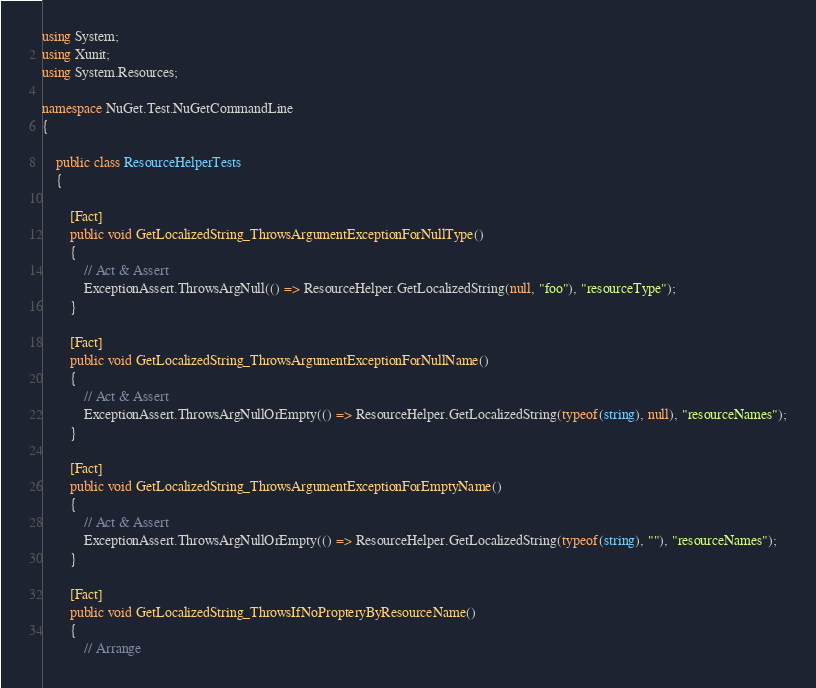<code> <loc_0><loc_0><loc_500><loc_500><_C#_>using System;
using Xunit;
using System.Resources;

namespace NuGet.Test.NuGetCommandLine
{

    public class ResourceHelperTests
    {

        [Fact]
        public void GetLocalizedString_ThrowsArgumentExceptionForNullType()
        {
            // Act & Assert
            ExceptionAssert.ThrowsArgNull(() => ResourceHelper.GetLocalizedString(null, "foo"), "resourceType");
        }

        [Fact]
        public void GetLocalizedString_ThrowsArgumentExceptionForNullName()
        {
            // Act & Assert
            ExceptionAssert.ThrowsArgNullOrEmpty(() => ResourceHelper.GetLocalizedString(typeof(string), null), "resourceNames");
        }

        [Fact]
        public void GetLocalizedString_ThrowsArgumentExceptionForEmptyName()
        {
            // Act & Assert
            ExceptionAssert.ThrowsArgNullOrEmpty(() => ResourceHelper.GetLocalizedString(typeof(string), ""), "resourceNames");
        }

        [Fact]
        public void GetLocalizedString_ThrowsIfNoPropteryByResourceName()
        {
            // Arrange </code> 